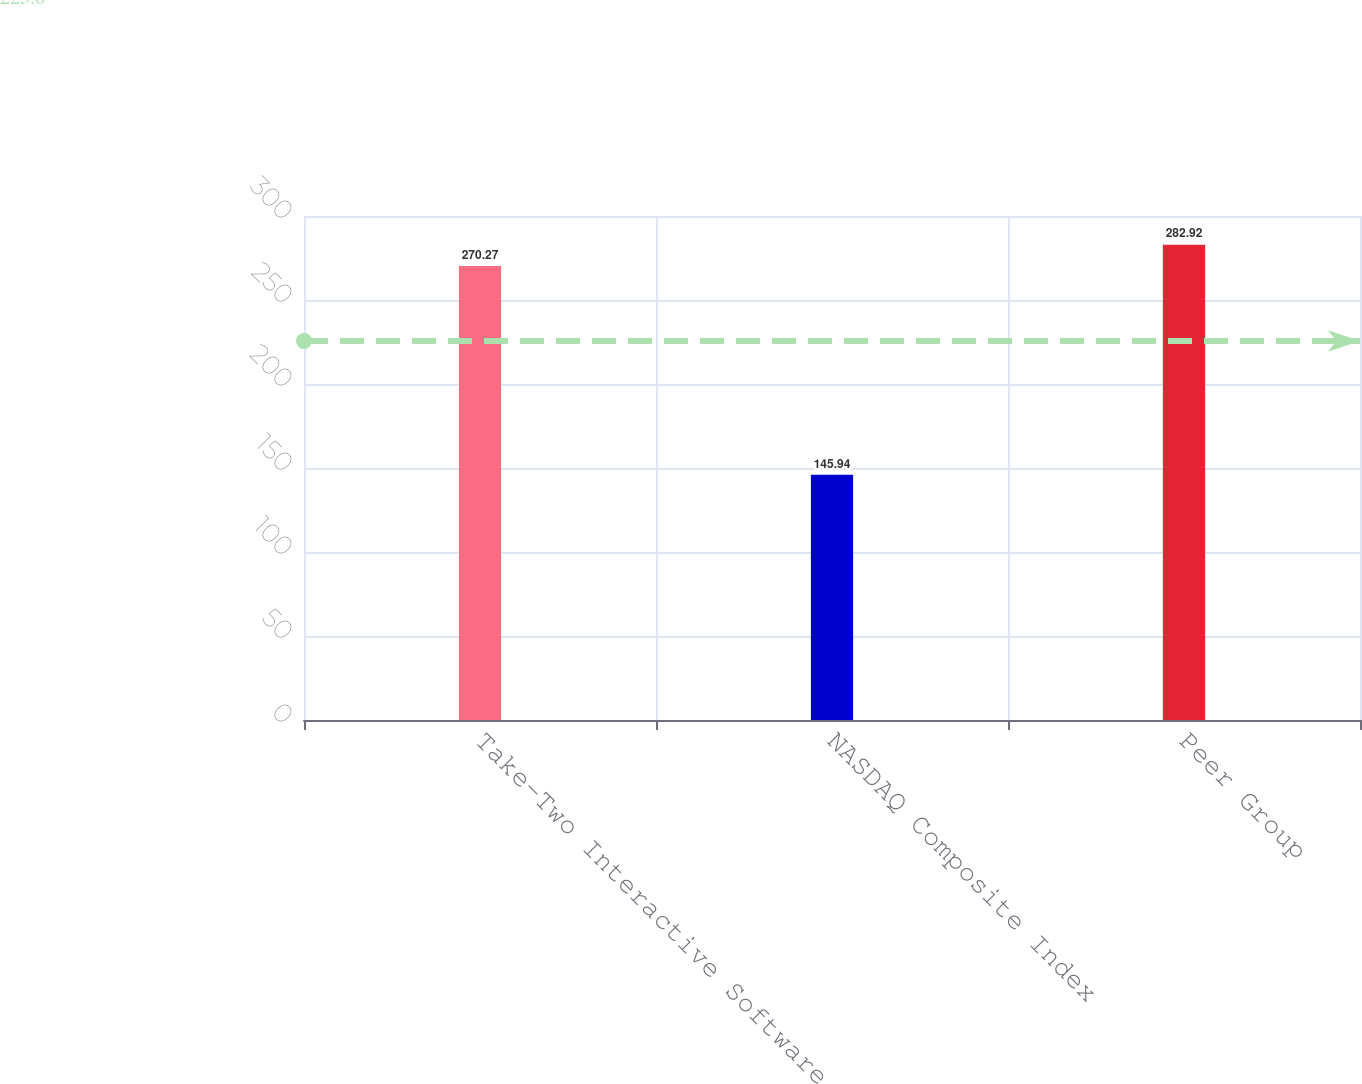Convert chart to OTSL. <chart><loc_0><loc_0><loc_500><loc_500><bar_chart><fcel>Take-Two Interactive Software<fcel>NASDAQ Composite Index<fcel>Peer Group<nl><fcel>270.27<fcel>145.94<fcel>282.92<nl></chart> 